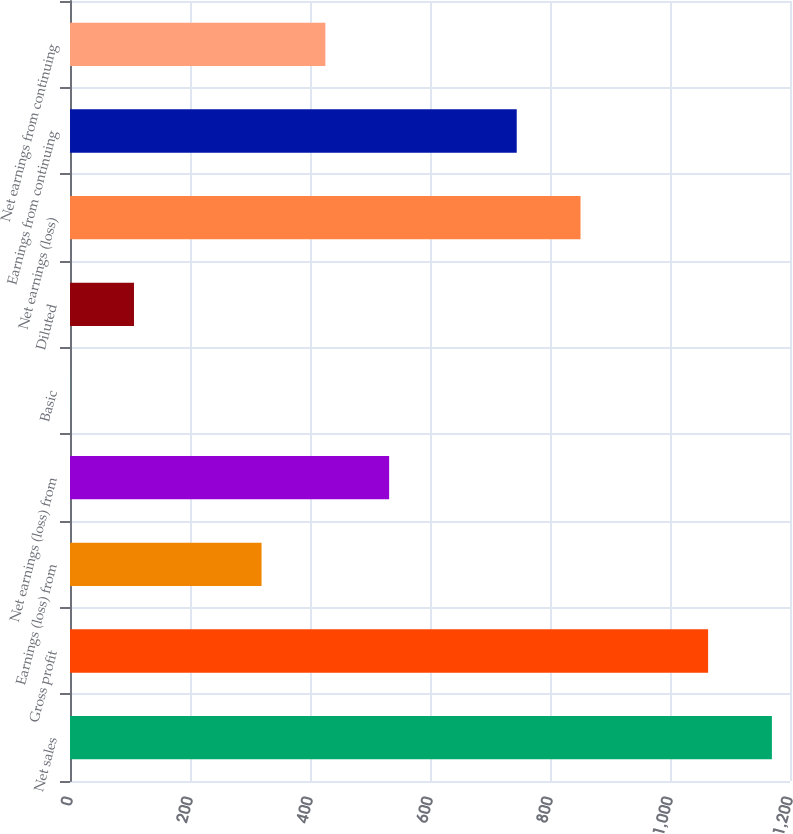<chart> <loc_0><loc_0><loc_500><loc_500><bar_chart><fcel>Net sales<fcel>Gross profit<fcel>Earnings (loss) from<fcel>Net earnings (loss) from<fcel>Basic<fcel>Diluted<fcel>Net earnings (loss)<fcel>Earnings from continuing<fcel>Net earnings from continuing<nl><fcel>1169.83<fcel>1063.51<fcel>319.27<fcel>531.91<fcel>0.31<fcel>106.63<fcel>850.87<fcel>744.55<fcel>425.59<nl></chart> 